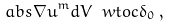Convert formula to latex. <formula><loc_0><loc_0><loc_500><loc_500>\ a b s { \nabla u } ^ { m } d V \ w t o c \delta _ { 0 } \, ,</formula> 